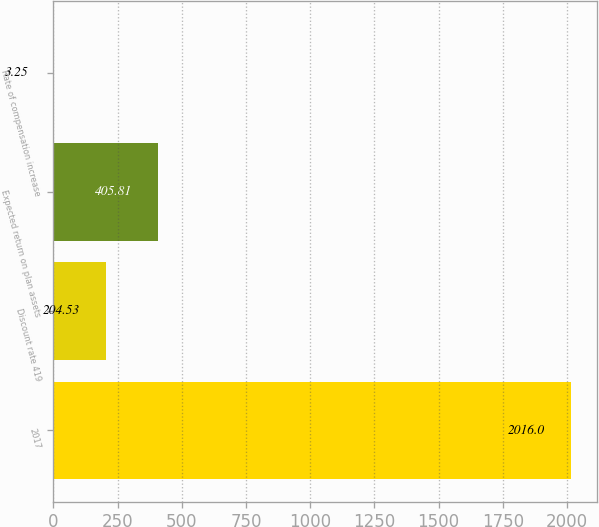<chart> <loc_0><loc_0><loc_500><loc_500><bar_chart><fcel>2017<fcel>Discount rate 419<fcel>Expected return on plan assets<fcel>Rate of compensation increase<nl><fcel>2016<fcel>204.53<fcel>405.81<fcel>3.25<nl></chart> 